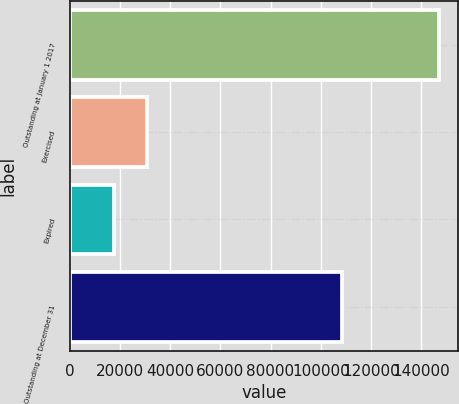<chart> <loc_0><loc_0><loc_500><loc_500><bar_chart><fcel>Outstanding at January 1 2017<fcel>Exercised<fcel>Expired<fcel>Outstanding at December 31<nl><fcel>147282<fcel>30782.4<fcel>17838<fcel>108438<nl></chart> 